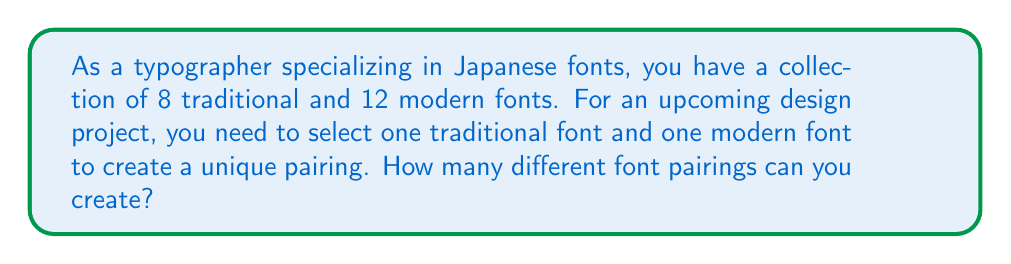Give your solution to this math problem. Let's approach this step-by-step:

1) We are selecting one font from each category:
   - One traditional font
   - One modern font

2) For the traditional font:
   - We have 8 options to choose from
   - We are selecting only 1 font

3) For the modern font:
   - We have 12 options to choose from
   - We are selecting only 1 font

4) This is a combination problem where we are making independent choices for each category. In such cases, we multiply the number of options for each choice.

5) The total number of possible pairings is:
   $$ \text{Total pairings} = \text{Traditional options} \times \text{Modern options} $$
   $$ \text{Total pairings} = 8 \times 12 $$
   $$ \text{Total pairings} = 96 $$

Therefore, you can create 96 different font pairings for your design project.
Answer: 96 